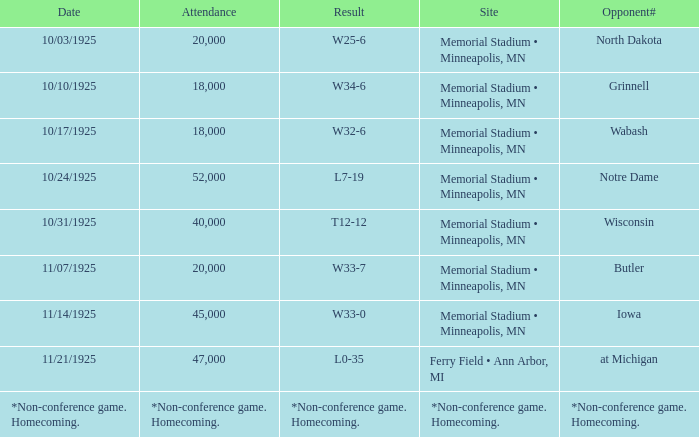Who was the opponent at the game attended by 45,000? Iowa. 